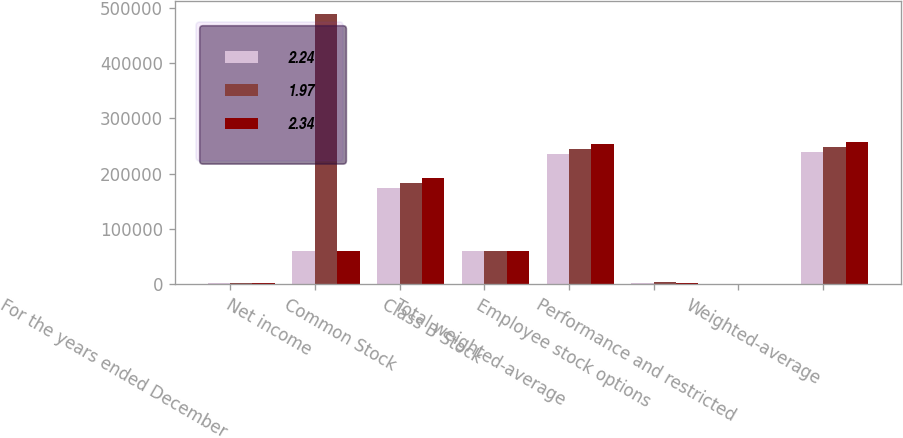Convert chart. <chart><loc_0><loc_0><loc_500><loc_500><stacked_bar_chart><ecel><fcel>For the years ended December<fcel>Net income<fcel>Common Stock<fcel>Class B Stock<fcel>Total weighted-average<fcel>Employee stock options<fcel>Performance and restricted<fcel>Weighted-average<nl><fcel>2.24<fcel>2006<fcel>60832.5<fcel>174722<fcel>60817<fcel>235539<fcel>2784<fcel>748<fcel>239071<nl><fcel>1.97<fcel>2005<fcel>488547<fcel>183747<fcel>60821<fcel>244568<fcel>3336<fcel>388<fcel>248292<nl><fcel>2.34<fcel>2004<fcel>60832.5<fcel>193037<fcel>60844<fcel>253881<fcel>2809<fcel>244<fcel>256934<nl></chart> 